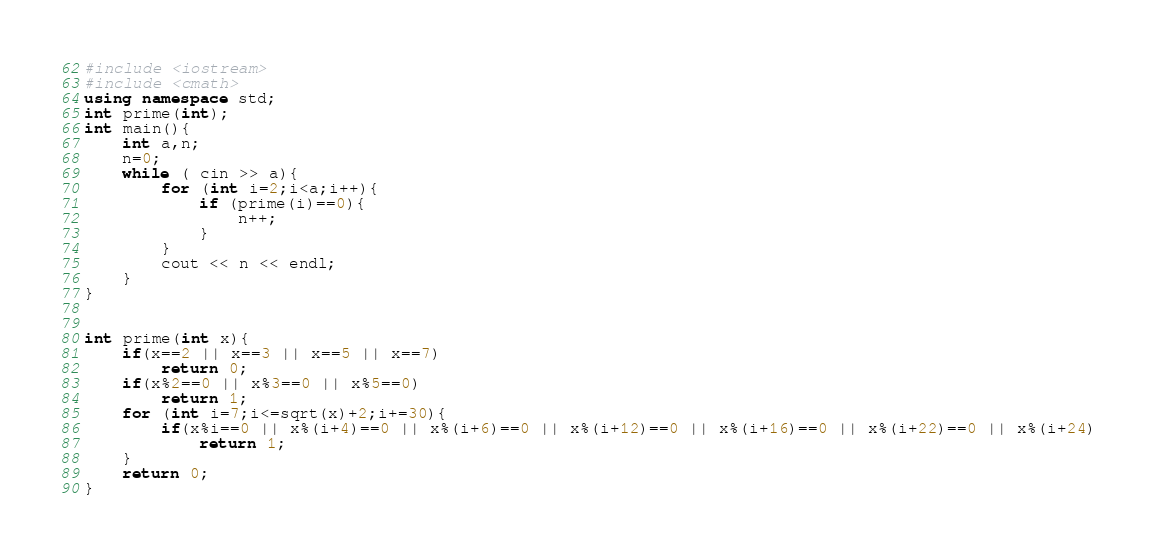Convert code to text. <code><loc_0><loc_0><loc_500><loc_500><_C++_>#include <iostream>
#include <cmath>
using namespace std;
int prime(int);
int main(){
    int a,n;
    n=0;
    while ( cin >> a){
        for (int i=2;i<a;i++){
            if (prime(i)==0){
                n++;
            }
        }
        cout << n << endl;
    }
}


int prime(int x){
    if(x==2 || x==3 || x==5 || x==7)
        return 0;
    if(x%2==0 || x%3==0 || x%5==0)
        return 1;
    for (int i=7;i<=sqrt(x)+2;i+=30){
        if(x%i==0 || x%(i+4)==0 || x%(i+6)==0 || x%(i+12)==0 || x%(i+16)==0 || x%(i+22)==0 || x%(i+24)
            return 1;
    }
    return 0;
}</code> 